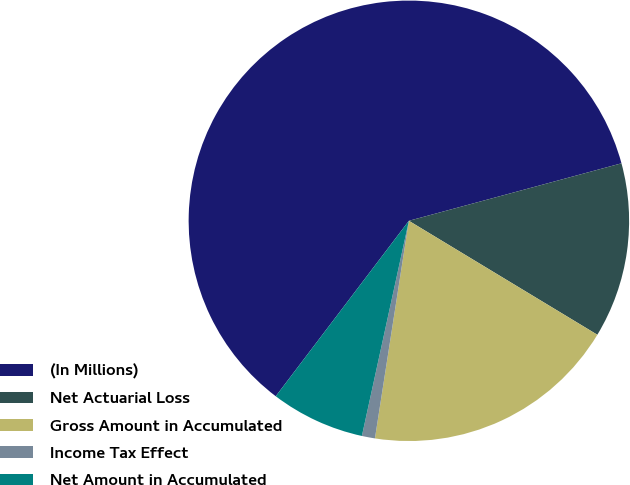Convert chart to OTSL. <chart><loc_0><loc_0><loc_500><loc_500><pie_chart><fcel>(In Millions)<fcel>Net Actuarial Loss<fcel>Gross Amount in Accumulated<fcel>Income Tax Effect<fcel>Net Amount in Accumulated<nl><fcel>60.47%<fcel>12.86%<fcel>18.81%<fcel>0.96%<fcel>6.91%<nl></chart> 